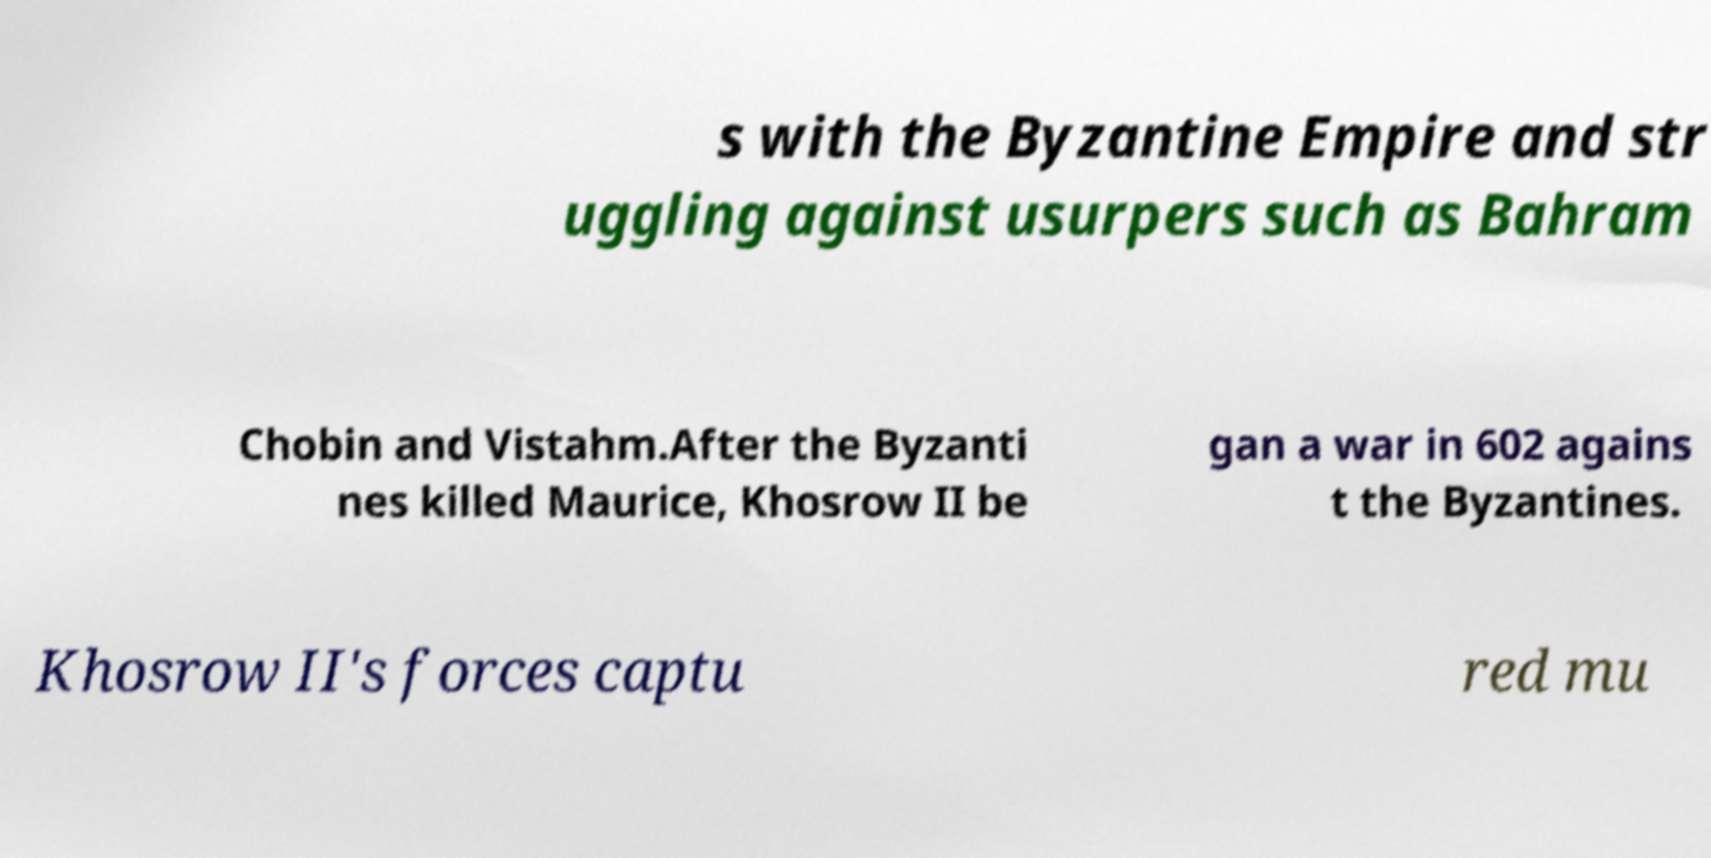Please read and relay the text visible in this image. What does it say? s with the Byzantine Empire and str uggling against usurpers such as Bahram Chobin and Vistahm.After the Byzanti nes killed Maurice, Khosrow II be gan a war in 602 agains t the Byzantines. Khosrow II's forces captu red mu 